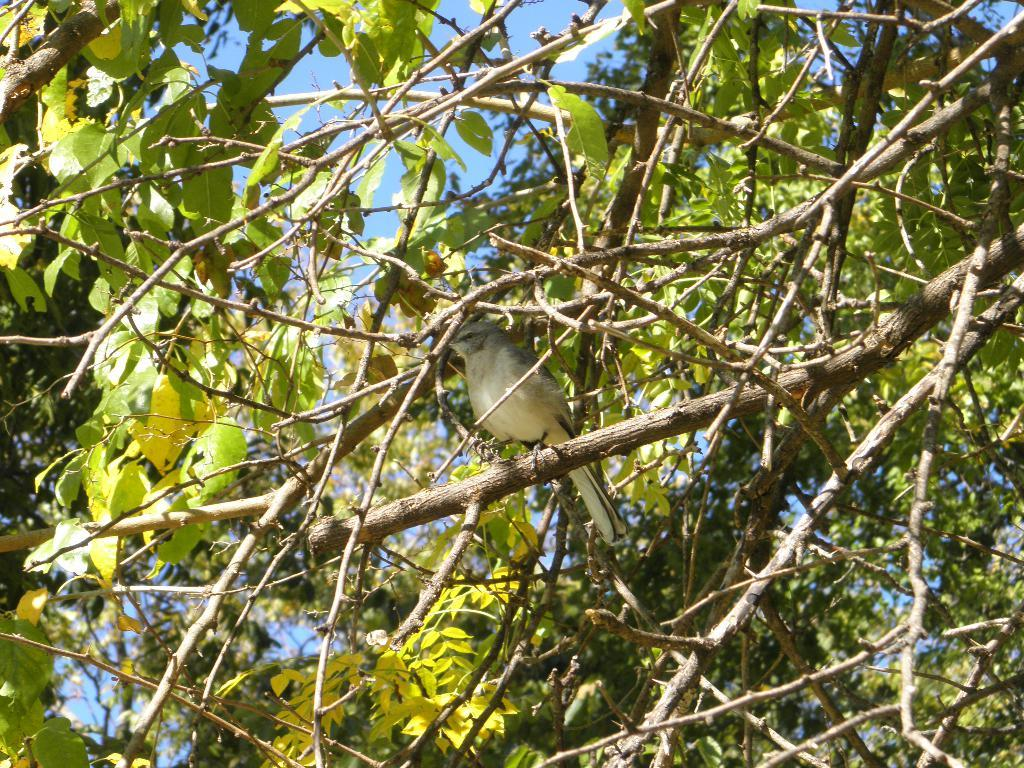What type of animal can be seen in the image? There is a bird in the image. Where is the bird located? The bird is on a tree. What colors are visible on the bird? The bird is in gray and white color. What is the color of the trees in the image? The trees are in green color. What color is the sky in the background? The sky is in blue color in the background. Are there any apples hanging from the tree in the image? There is no mention of apples in the provided facts, and the image does not show any apples on the tree. 